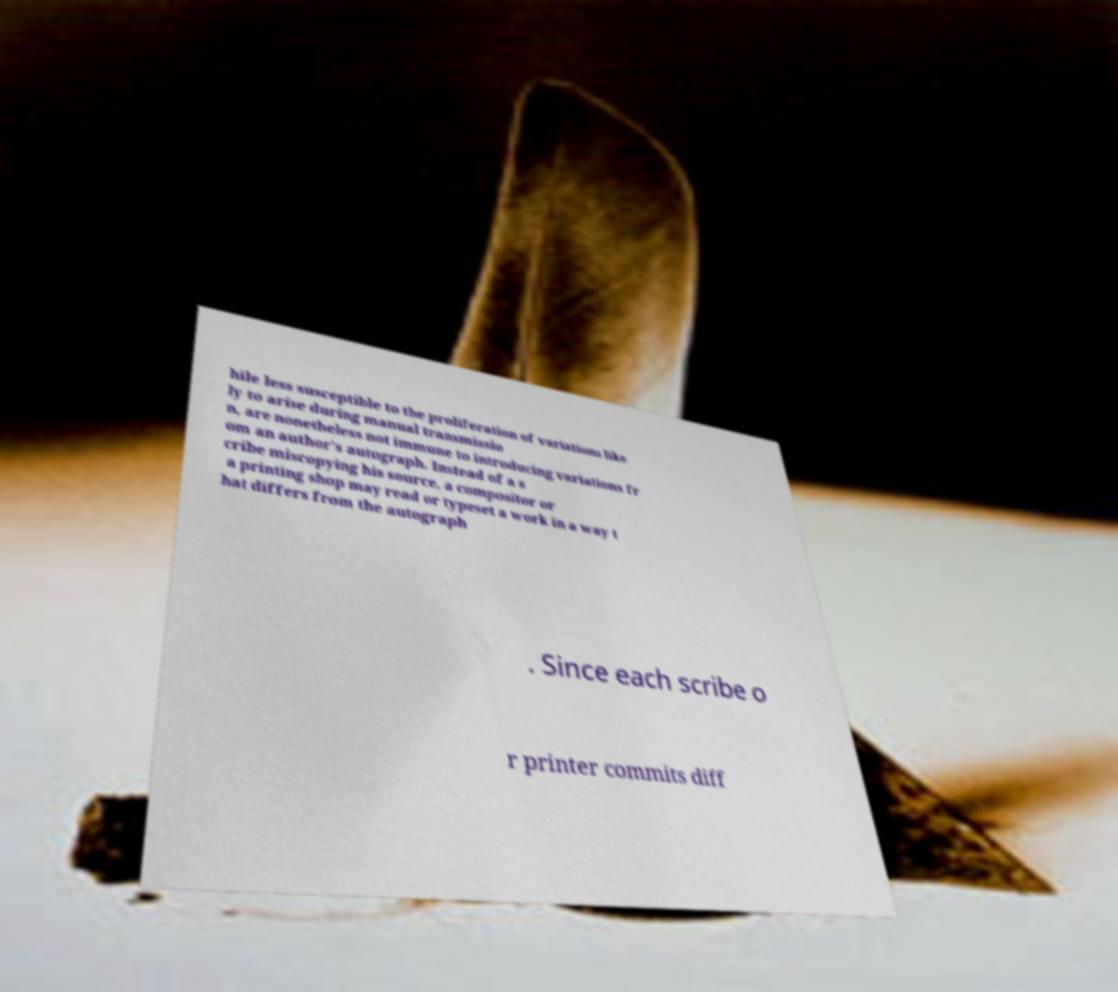Please read and relay the text visible in this image. What does it say? hile less susceptible to the proliferation of variations like ly to arise during manual transmissio n, are nonetheless not immune to introducing variations fr om an author's autograph. Instead of a s cribe miscopying his source, a compositor or a printing shop may read or typeset a work in a way t hat differs from the autograph . Since each scribe o r printer commits diff 